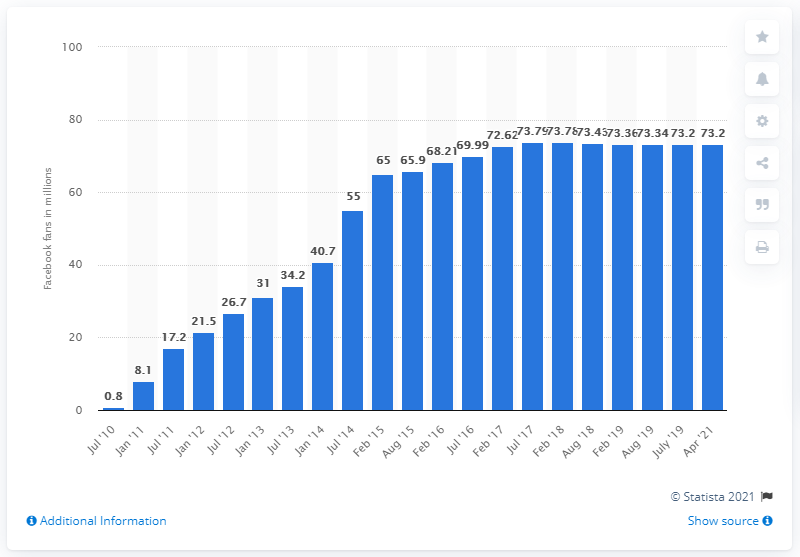Outline some significant characteristics in this image. In April 2021, Manchester United had 72,620 fans on their Facebook page. 